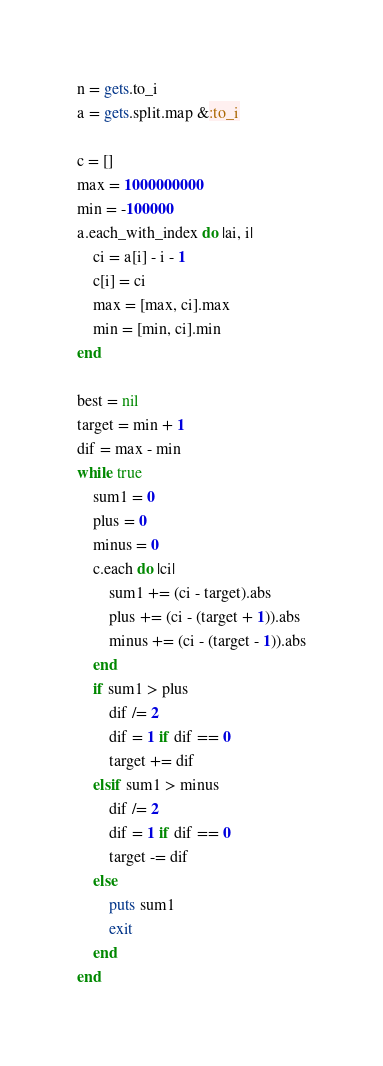Convert code to text. <code><loc_0><loc_0><loc_500><loc_500><_Ruby_>n = gets.to_i
a = gets.split.map &:to_i

c = []
max = 1000000000
min = -100000
a.each_with_index do |ai, i|
    ci = a[i] - i - 1
    c[i] = ci
    max = [max, ci].max
    min = [min, ci].min
end

best = nil
target = min + 1
dif = max - min
while true
    sum1 = 0
    plus = 0
    minus = 0
    c.each do |ci|
        sum1 += (ci - target).abs
        plus += (ci - (target + 1)).abs
        minus += (ci - (target - 1)).abs
    end
    if sum1 > plus
        dif /= 2
        dif = 1 if dif == 0
        target += dif
    elsif sum1 > minus
        dif /= 2
        dif = 1 if dif == 0
        target -= dif
    else
        puts sum1
        exit
    end
end</code> 